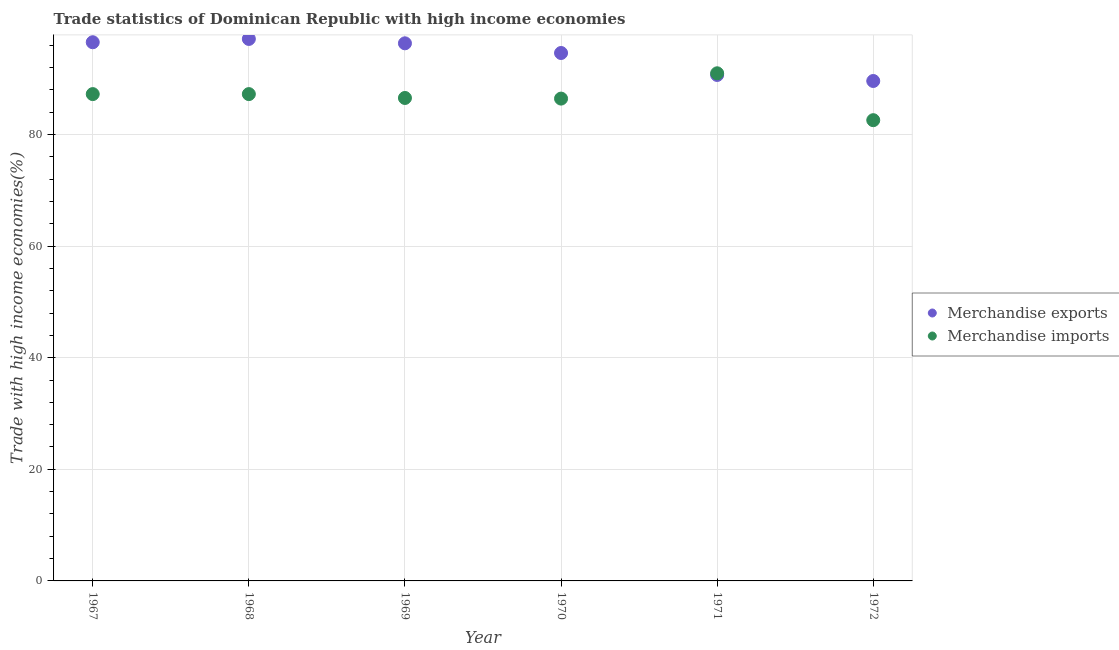How many different coloured dotlines are there?
Your answer should be compact. 2. What is the merchandise imports in 1971?
Your response must be concise. 90.97. Across all years, what is the maximum merchandise imports?
Provide a succinct answer. 90.97. Across all years, what is the minimum merchandise imports?
Offer a terse response. 82.57. In which year was the merchandise exports maximum?
Give a very brief answer. 1968. What is the total merchandise exports in the graph?
Your answer should be compact. 564.87. What is the difference between the merchandise imports in 1968 and that in 1972?
Offer a terse response. 4.67. What is the difference between the merchandise exports in 1967 and the merchandise imports in 1971?
Offer a terse response. 5.56. What is the average merchandise exports per year?
Your answer should be very brief. 94.14. In the year 1972, what is the difference between the merchandise imports and merchandise exports?
Provide a succinct answer. -7.02. In how many years, is the merchandise imports greater than 68 %?
Provide a succinct answer. 6. What is the ratio of the merchandise exports in 1968 to that in 1971?
Offer a terse response. 1.07. Is the merchandise exports in 1967 less than that in 1971?
Ensure brevity in your answer.  No. Is the difference between the merchandise imports in 1968 and 1972 greater than the difference between the merchandise exports in 1968 and 1972?
Your answer should be very brief. No. What is the difference between the highest and the second highest merchandise exports?
Your response must be concise. 0.59. What is the difference between the highest and the lowest merchandise imports?
Your response must be concise. 8.4. In how many years, is the merchandise imports greater than the average merchandise imports taken over all years?
Give a very brief answer. 3. Is the sum of the merchandise exports in 1967 and 1970 greater than the maximum merchandise imports across all years?
Offer a very short reply. Yes. Is the merchandise exports strictly less than the merchandise imports over the years?
Your answer should be very brief. No. How many dotlines are there?
Make the answer very short. 2. Are the values on the major ticks of Y-axis written in scientific E-notation?
Your response must be concise. No. Does the graph contain any zero values?
Ensure brevity in your answer.  No. Does the graph contain grids?
Offer a terse response. Yes. Where does the legend appear in the graph?
Provide a succinct answer. Center right. What is the title of the graph?
Offer a terse response. Trade statistics of Dominican Republic with high income economies. Does "Number of arrivals" appear as one of the legend labels in the graph?
Offer a terse response. No. What is the label or title of the Y-axis?
Provide a short and direct response. Trade with high income economies(%). What is the Trade with high income economies(%) of Merchandise exports in 1967?
Your answer should be very brief. 96.53. What is the Trade with high income economies(%) in Merchandise imports in 1967?
Your answer should be compact. 87.24. What is the Trade with high income economies(%) in Merchandise exports in 1968?
Offer a very short reply. 97.13. What is the Trade with high income economies(%) in Merchandise imports in 1968?
Offer a terse response. 87.24. What is the Trade with high income economies(%) in Merchandise exports in 1969?
Keep it short and to the point. 96.34. What is the Trade with high income economies(%) of Merchandise imports in 1969?
Your response must be concise. 86.55. What is the Trade with high income economies(%) in Merchandise exports in 1970?
Provide a succinct answer. 94.61. What is the Trade with high income economies(%) of Merchandise imports in 1970?
Your answer should be very brief. 86.43. What is the Trade with high income economies(%) of Merchandise exports in 1971?
Provide a succinct answer. 90.67. What is the Trade with high income economies(%) in Merchandise imports in 1971?
Offer a very short reply. 90.97. What is the Trade with high income economies(%) in Merchandise exports in 1972?
Ensure brevity in your answer.  89.59. What is the Trade with high income economies(%) of Merchandise imports in 1972?
Your answer should be compact. 82.57. Across all years, what is the maximum Trade with high income economies(%) of Merchandise exports?
Provide a succinct answer. 97.13. Across all years, what is the maximum Trade with high income economies(%) of Merchandise imports?
Offer a terse response. 90.97. Across all years, what is the minimum Trade with high income economies(%) of Merchandise exports?
Give a very brief answer. 89.59. Across all years, what is the minimum Trade with high income economies(%) of Merchandise imports?
Provide a succinct answer. 82.57. What is the total Trade with high income economies(%) in Merchandise exports in the graph?
Your answer should be very brief. 564.87. What is the total Trade with high income economies(%) in Merchandise imports in the graph?
Your answer should be very brief. 521. What is the difference between the Trade with high income economies(%) of Merchandise exports in 1967 and that in 1968?
Your answer should be very brief. -0.59. What is the difference between the Trade with high income economies(%) in Merchandise imports in 1967 and that in 1968?
Your answer should be very brief. -0. What is the difference between the Trade with high income economies(%) of Merchandise exports in 1967 and that in 1969?
Provide a short and direct response. 0.19. What is the difference between the Trade with high income economies(%) in Merchandise imports in 1967 and that in 1969?
Make the answer very short. 0.69. What is the difference between the Trade with high income economies(%) of Merchandise exports in 1967 and that in 1970?
Give a very brief answer. 1.93. What is the difference between the Trade with high income economies(%) of Merchandise imports in 1967 and that in 1970?
Provide a short and direct response. 0.81. What is the difference between the Trade with high income economies(%) in Merchandise exports in 1967 and that in 1971?
Give a very brief answer. 5.86. What is the difference between the Trade with high income economies(%) in Merchandise imports in 1967 and that in 1971?
Ensure brevity in your answer.  -3.73. What is the difference between the Trade with high income economies(%) of Merchandise exports in 1967 and that in 1972?
Give a very brief answer. 6.94. What is the difference between the Trade with high income economies(%) of Merchandise imports in 1967 and that in 1972?
Provide a succinct answer. 4.67. What is the difference between the Trade with high income economies(%) in Merchandise exports in 1968 and that in 1969?
Keep it short and to the point. 0.78. What is the difference between the Trade with high income economies(%) in Merchandise imports in 1968 and that in 1969?
Keep it short and to the point. 0.69. What is the difference between the Trade with high income economies(%) of Merchandise exports in 1968 and that in 1970?
Your answer should be very brief. 2.52. What is the difference between the Trade with high income economies(%) of Merchandise imports in 1968 and that in 1970?
Offer a terse response. 0.81. What is the difference between the Trade with high income economies(%) in Merchandise exports in 1968 and that in 1971?
Your answer should be very brief. 6.45. What is the difference between the Trade with high income economies(%) in Merchandise imports in 1968 and that in 1971?
Provide a succinct answer. -3.73. What is the difference between the Trade with high income economies(%) in Merchandise exports in 1968 and that in 1972?
Provide a short and direct response. 7.54. What is the difference between the Trade with high income economies(%) in Merchandise imports in 1968 and that in 1972?
Offer a terse response. 4.67. What is the difference between the Trade with high income economies(%) of Merchandise exports in 1969 and that in 1970?
Keep it short and to the point. 1.74. What is the difference between the Trade with high income economies(%) of Merchandise imports in 1969 and that in 1970?
Offer a very short reply. 0.11. What is the difference between the Trade with high income economies(%) in Merchandise exports in 1969 and that in 1971?
Your answer should be very brief. 5.67. What is the difference between the Trade with high income economies(%) in Merchandise imports in 1969 and that in 1971?
Give a very brief answer. -4.42. What is the difference between the Trade with high income economies(%) in Merchandise exports in 1969 and that in 1972?
Give a very brief answer. 6.75. What is the difference between the Trade with high income economies(%) of Merchandise imports in 1969 and that in 1972?
Keep it short and to the point. 3.98. What is the difference between the Trade with high income economies(%) in Merchandise exports in 1970 and that in 1971?
Make the answer very short. 3.93. What is the difference between the Trade with high income economies(%) of Merchandise imports in 1970 and that in 1971?
Offer a very short reply. -4.53. What is the difference between the Trade with high income economies(%) of Merchandise exports in 1970 and that in 1972?
Offer a terse response. 5.02. What is the difference between the Trade with high income economies(%) of Merchandise imports in 1970 and that in 1972?
Give a very brief answer. 3.87. What is the difference between the Trade with high income economies(%) in Merchandise exports in 1971 and that in 1972?
Your answer should be very brief. 1.08. What is the difference between the Trade with high income economies(%) of Merchandise imports in 1971 and that in 1972?
Offer a very short reply. 8.4. What is the difference between the Trade with high income economies(%) of Merchandise exports in 1967 and the Trade with high income economies(%) of Merchandise imports in 1968?
Your response must be concise. 9.29. What is the difference between the Trade with high income economies(%) of Merchandise exports in 1967 and the Trade with high income economies(%) of Merchandise imports in 1969?
Provide a short and direct response. 9.99. What is the difference between the Trade with high income economies(%) of Merchandise exports in 1967 and the Trade with high income economies(%) of Merchandise imports in 1970?
Offer a terse response. 10.1. What is the difference between the Trade with high income economies(%) of Merchandise exports in 1967 and the Trade with high income economies(%) of Merchandise imports in 1971?
Make the answer very short. 5.56. What is the difference between the Trade with high income economies(%) of Merchandise exports in 1967 and the Trade with high income economies(%) of Merchandise imports in 1972?
Your answer should be compact. 13.97. What is the difference between the Trade with high income economies(%) in Merchandise exports in 1968 and the Trade with high income economies(%) in Merchandise imports in 1969?
Give a very brief answer. 10.58. What is the difference between the Trade with high income economies(%) in Merchandise exports in 1968 and the Trade with high income economies(%) in Merchandise imports in 1970?
Provide a short and direct response. 10.69. What is the difference between the Trade with high income economies(%) in Merchandise exports in 1968 and the Trade with high income economies(%) in Merchandise imports in 1971?
Provide a succinct answer. 6.16. What is the difference between the Trade with high income economies(%) of Merchandise exports in 1968 and the Trade with high income economies(%) of Merchandise imports in 1972?
Provide a succinct answer. 14.56. What is the difference between the Trade with high income economies(%) of Merchandise exports in 1969 and the Trade with high income economies(%) of Merchandise imports in 1970?
Keep it short and to the point. 9.91. What is the difference between the Trade with high income economies(%) in Merchandise exports in 1969 and the Trade with high income economies(%) in Merchandise imports in 1971?
Offer a very short reply. 5.37. What is the difference between the Trade with high income economies(%) of Merchandise exports in 1969 and the Trade with high income economies(%) of Merchandise imports in 1972?
Keep it short and to the point. 13.77. What is the difference between the Trade with high income economies(%) in Merchandise exports in 1970 and the Trade with high income economies(%) in Merchandise imports in 1971?
Offer a very short reply. 3.64. What is the difference between the Trade with high income economies(%) in Merchandise exports in 1970 and the Trade with high income economies(%) in Merchandise imports in 1972?
Give a very brief answer. 12.04. What is the difference between the Trade with high income economies(%) of Merchandise exports in 1971 and the Trade with high income economies(%) of Merchandise imports in 1972?
Keep it short and to the point. 8.1. What is the average Trade with high income economies(%) in Merchandise exports per year?
Offer a very short reply. 94.14. What is the average Trade with high income economies(%) of Merchandise imports per year?
Ensure brevity in your answer.  86.83. In the year 1967, what is the difference between the Trade with high income economies(%) of Merchandise exports and Trade with high income economies(%) of Merchandise imports?
Your response must be concise. 9.29. In the year 1968, what is the difference between the Trade with high income economies(%) in Merchandise exports and Trade with high income economies(%) in Merchandise imports?
Provide a short and direct response. 9.89. In the year 1969, what is the difference between the Trade with high income economies(%) of Merchandise exports and Trade with high income economies(%) of Merchandise imports?
Ensure brevity in your answer.  9.8. In the year 1970, what is the difference between the Trade with high income economies(%) in Merchandise exports and Trade with high income economies(%) in Merchandise imports?
Your answer should be compact. 8.17. In the year 1971, what is the difference between the Trade with high income economies(%) in Merchandise exports and Trade with high income economies(%) in Merchandise imports?
Make the answer very short. -0.3. In the year 1972, what is the difference between the Trade with high income economies(%) in Merchandise exports and Trade with high income economies(%) in Merchandise imports?
Your answer should be very brief. 7.02. What is the ratio of the Trade with high income economies(%) of Merchandise exports in 1967 to that in 1970?
Provide a succinct answer. 1.02. What is the ratio of the Trade with high income economies(%) in Merchandise imports in 1967 to that in 1970?
Offer a terse response. 1.01. What is the ratio of the Trade with high income economies(%) in Merchandise exports in 1967 to that in 1971?
Your response must be concise. 1.06. What is the ratio of the Trade with high income economies(%) of Merchandise imports in 1967 to that in 1971?
Offer a very short reply. 0.96. What is the ratio of the Trade with high income economies(%) in Merchandise exports in 1967 to that in 1972?
Keep it short and to the point. 1.08. What is the ratio of the Trade with high income economies(%) in Merchandise imports in 1967 to that in 1972?
Provide a succinct answer. 1.06. What is the ratio of the Trade with high income economies(%) of Merchandise imports in 1968 to that in 1969?
Give a very brief answer. 1.01. What is the ratio of the Trade with high income economies(%) of Merchandise exports in 1968 to that in 1970?
Make the answer very short. 1.03. What is the ratio of the Trade with high income economies(%) in Merchandise imports in 1968 to that in 1970?
Offer a very short reply. 1.01. What is the ratio of the Trade with high income economies(%) in Merchandise exports in 1968 to that in 1971?
Your response must be concise. 1.07. What is the ratio of the Trade with high income economies(%) in Merchandise imports in 1968 to that in 1971?
Your response must be concise. 0.96. What is the ratio of the Trade with high income economies(%) of Merchandise exports in 1968 to that in 1972?
Give a very brief answer. 1.08. What is the ratio of the Trade with high income economies(%) of Merchandise imports in 1968 to that in 1972?
Your answer should be compact. 1.06. What is the ratio of the Trade with high income economies(%) of Merchandise exports in 1969 to that in 1970?
Provide a succinct answer. 1.02. What is the ratio of the Trade with high income economies(%) of Merchandise exports in 1969 to that in 1971?
Your response must be concise. 1.06. What is the ratio of the Trade with high income economies(%) of Merchandise imports in 1969 to that in 1971?
Give a very brief answer. 0.95. What is the ratio of the Trade with high income economies(%) of Merchandise exports in 1969 to that in 1972?
Provide a succinct answer. 1.08. What is the ratio of the Trade with high income economies(%) of Merchandise imports in 1969 to that in 1972?
Your response must be concise. 1.05. What is the ratio of the Trade with high income economies(%) of Merchandise exports in 1970 to that in 1971?
Ensure brevity in your answer.  1.04. What is the ratio of the Trade with high income economies(%) in Merchandise imports in 1970 to that in 1971?
Your response must be concise. 0.95. What is the ratio of the Trade with high income economies(%) of Merchandise exports in 1970 to that in 1972?
Your response must be concise. 1.06. What is the ratio of the Trade with high income economies(%) of Merchandise imports in 1970 to that in 1972?
Keep it short and to the point. 1.05. What is the ratio of the Trade with high income economies(%) in Merchandise exports in 1971 to that in 1972?
Your response must be concise. 1.01. What is the ratio of the Trade with high income economies(%) of Merchandise imports in 1971 to that in 1972?
Offer a terse response. 1.1. What is the difference between the highest and the second highest Trade with high income economies(%) of Merchandise exports?
Provide a succinct answer. 0.59. What is the difference between the highest and the second highest Trade with high income economies(%) in Merchandise imports?
Your answer should be very brief. 3.73. What is the difference between the highest and the lowest Trade with high income economies(%) of Merchandise exports?
Provide a succinct answer. 7.54. What is the difference between the highest and the lowest Trade with high income economies(%) of Merchandise imports?
Offer a terse response. 8.4. 